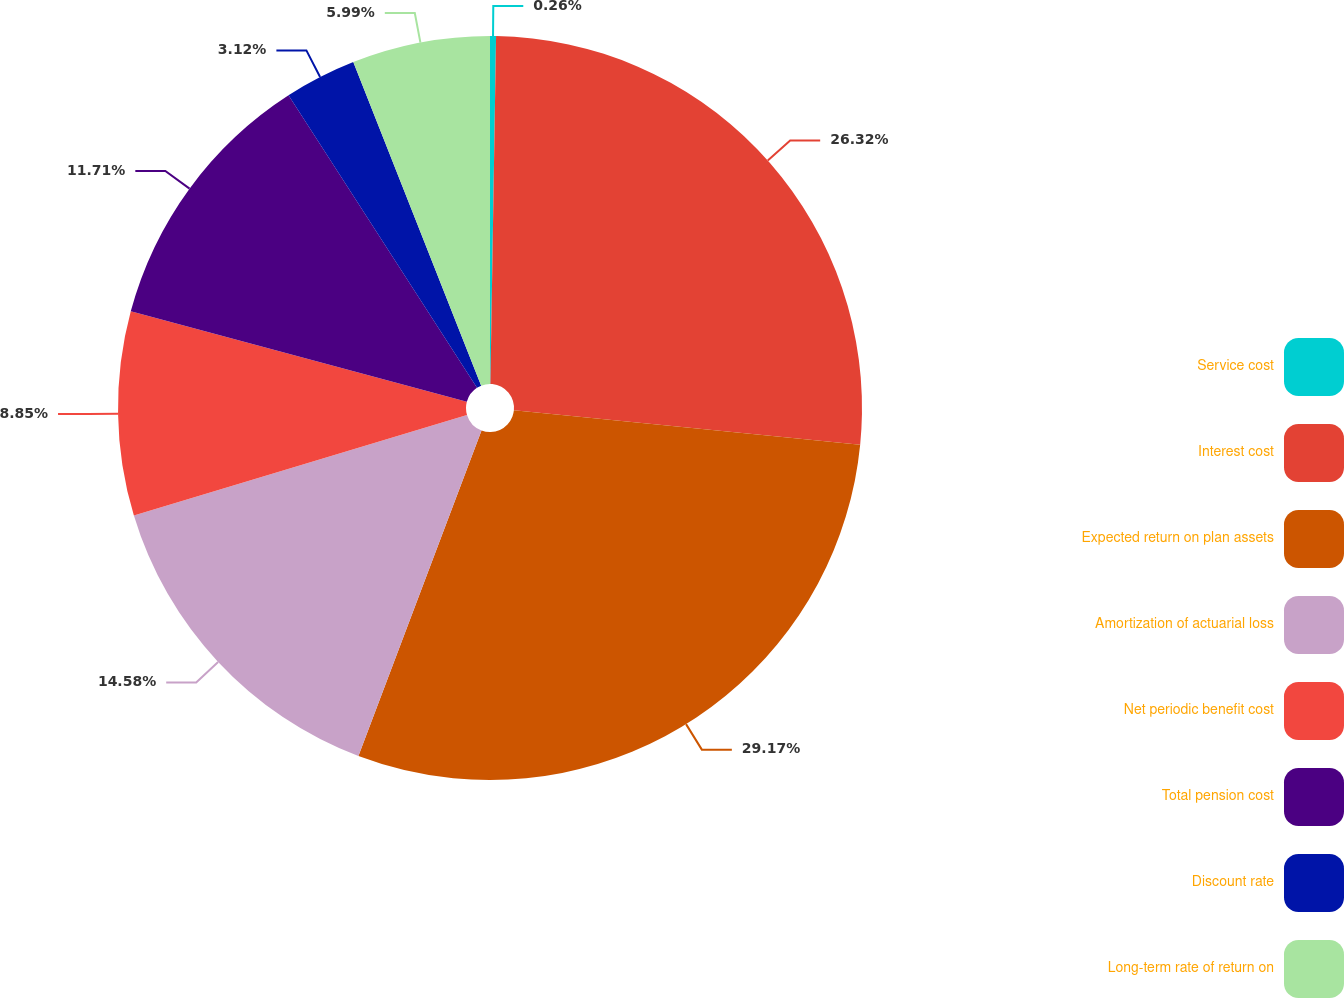Convert chart. <chart><loc_0><loc_0><loc_500><loc_500><pie_chart><fcel>Service cost<fcel>Interest cost<fcel>Expected return on plan assets<fcel>Amortization of actuarial loss<fcel>Net periodic benefit cost<fcel>Total pension cost<fcel>Discount rate<fcel>Long-term rate of return on<nl><fcel>0.26%<fcel>26.32%<fcel>29.18%<fcel>14.58%<fcel>8.85%<fcel>11.71%<fcel>3.12%<fcel>5.99%<nl></chart> 